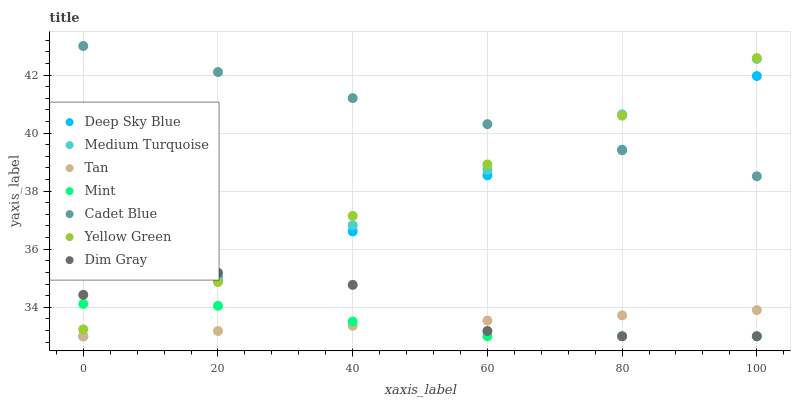Does Mint have the minimum area under the curve?
Answer yes or no. Yes. Does Cadet Blue have the maximum area under the curve?
Answer yes or no. Yes. Does Deep Sky Blue have the minimum area under the curve?
Answer yes or no. No. Does Deep Sky Blue have the maximum area under the curve?
Answer yes or no. No. Is Medium Turquoise the smoothest?
Answer yes or no. Yes. Is Dim Gray the roughest?
Answer yes or no. Yes. Is Deep Sky Blue the smoothest?
Answer yes or no. No. Is Deep Sky Blue the roughest?
Answer yes or no. No. Does Deep Sky Blue have the lowest value?
Answer yes or no. Yes. Does Yellow Green have the lowest value?
Answer yes or no. No. Does Cadet Blue have the highest value?
Answer yes or no. Yes. Does Deep Sky Blue have the highest value?
Answer yes or no. No. Is Tan less than Yellow Green?
Answer yes or no. Yes. Is Cadet Blue greater than Tan?
Answer yes or no. Yes. Does Dim Gray intersect Medium Turquoise?
Answer yes or no. Yes. Is Dim Gray less than Medium Turquoise?
Answer yes or no. No. Is Dim Gray greater than Medium Turquoise?
Answer yes or no. No. Does Tan intersect Yellow Green?
Answer yes or no. No. 